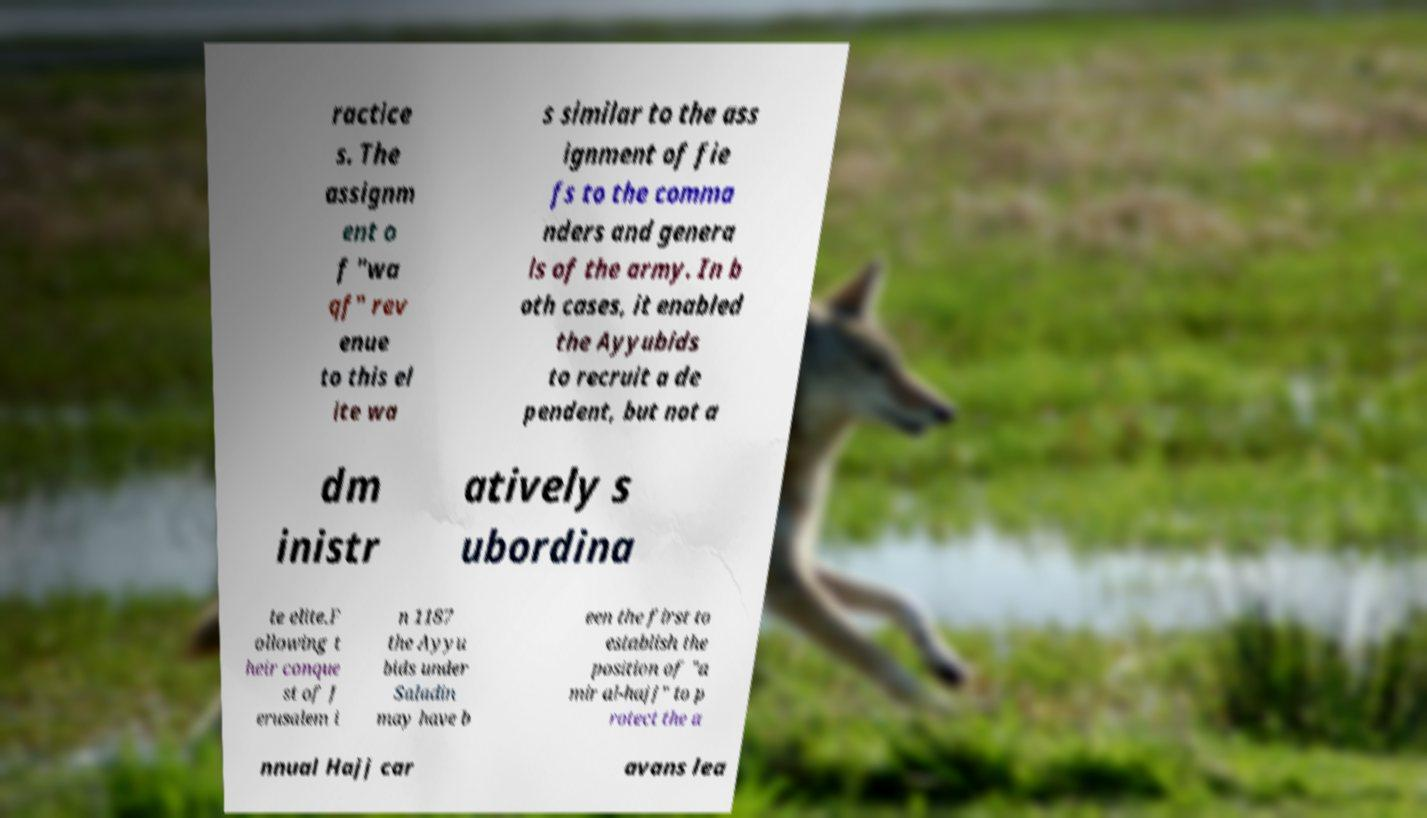What messages or text are displayed in this image? I need them in a readable, typed format. ractice s. The assignm ent o f "wa qf" rev enue to this el ite wa s similar to the ass ignment of fie fs to the comma nders and genera ls of the army. In b oth cases, it enabled the Ayyubids to recruit a de pendent, but not a dm inistr atively s ubordina te elite.F ollowing t heir conque st of J erusalem i n 1187 the Ayyu bids under Saladin may have b een the first to establish the position of "a mir al-hajj" to p rotect the a nnual Hajj car avans lea 